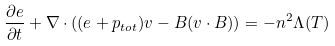<formula> <loc_0><loc_0><loc_500><loc_500>\frac { \partial e } { \partial t } + \nabla \cdot ( ( e + p _ { t o t } ) { v } - { B } ( { v } \cdot { B } ) ) = - n ^ { 2 } \Lambda ( T )</formula> 